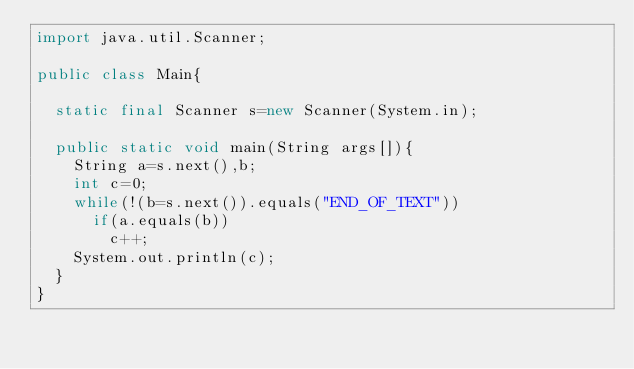<code> <loc_0><loc_0><loc_500><loc_500><_Java_>import java.util.Scanner;

public class Main{

	static final Scanner s=new Scanner(System.in);

	public static void main(String args[]){
		String a=s.next(),b;
		int c=0;
		while(!(b=s.next()).equals("END_OF_TEXT"))
			if(a.equals(b))
				c++;
		System.out.println(c);
	}
}</code> 